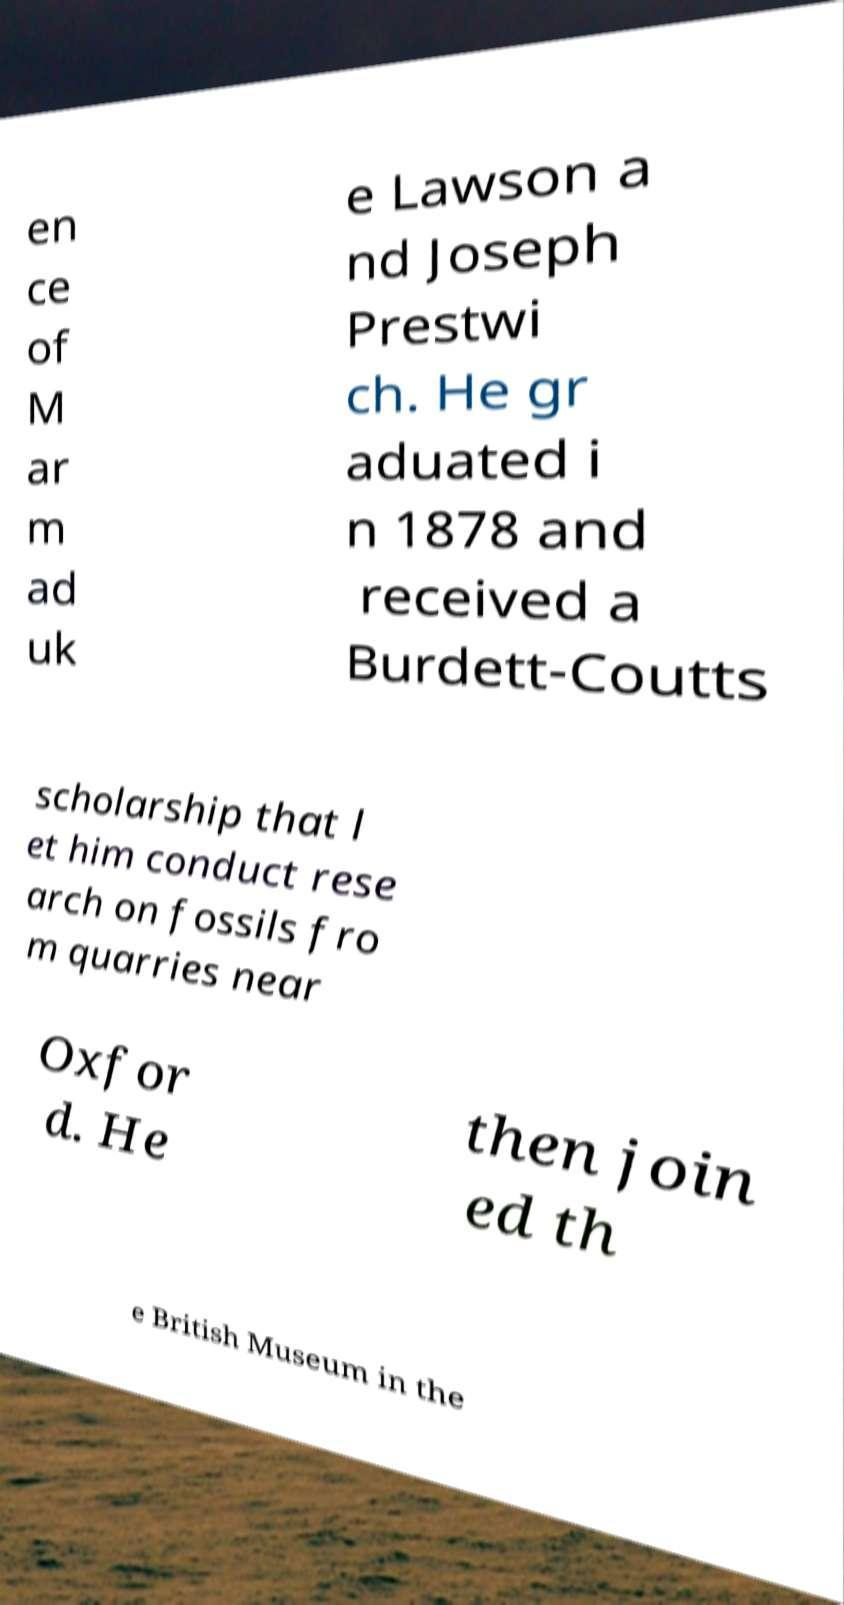Please identify and transcribe the text found in this image. en ce of M ar m ad uk e Lawson a nd Joseph Prestwi ch. He gr aduated i n 1878 and received a Burdett-Coutts scholarship that l et him conduct rese arch on fossils fro m quarries near Oxfor d. He then join ed th e British Museum in the 